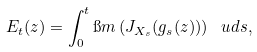<formula> <loc_0><loc_0><loc_500><loc_500>E _ { t } ( z ) = \int _ { 0 } ^ { t } \i m \left ( J _ { X _ { s } } ( g _ { s } ( z ) ) \right ) \, \ u d s ,</formula> 